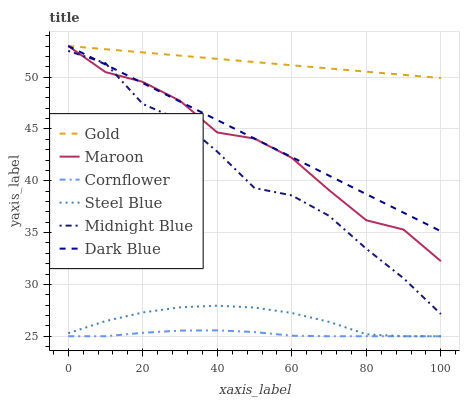Does Cornflower have the minimum area under the curve?
Answer yes or no. Yes. Does Gold have the maximum area under the curve?
Answer yes or no. Yes. Does Midnight Blue have the minimum area under the curve?
Answer yes or no. No. Does Midnight Blue have the maximum area under the curve?
Answer yes or no. No. Is Dark Blue the smoothest?
Answer yes or no. Yes. Is Midnight Blue the roughest?
Answer yes or no. Yes. Is Gold the smoothest?
Answer yes or no. No. Is Gold the roughest?
Answer yes or no. No. Does Cornflower have the lowest value?
Answer yes or no. Yes. Does Midnight Blue have the lowest value?
Answer yes or no. No. Does Dark Blue have the highest value?
Answer yes or no. Yes. Does Midnight Blue have the highest value?
Answer yes or no. No. Is Cornflower less than Midnight Blue?
Answer yes or no. Yes. Is Gold greater than Midnight Blue?
Answer yes or no. Yes. Does Dark Blue intersect Maroon?
Answer yes or no. Yes. Is Dark Blue less than Maroon?
Answer yes or no. No. Is Dark Blue greater than Maroon?
Answer yes or no. No. Does Cornflower intersect Midnight Blue?
Answer yes or no. No. 